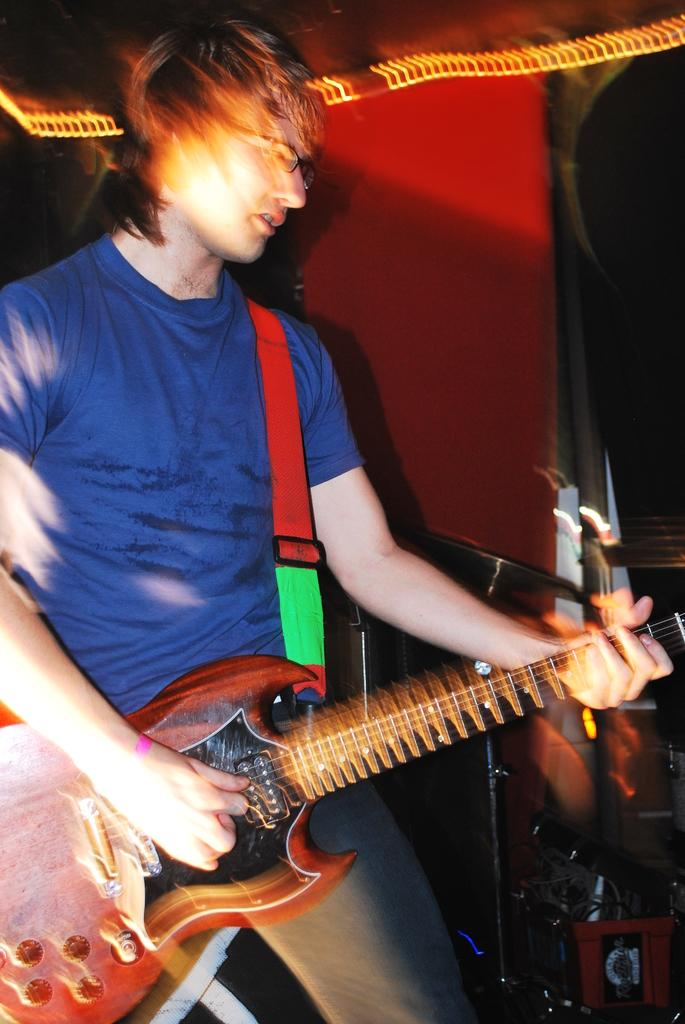What is the person in the image doing? The person is standing in the image and holding a guitar. What other musical instrument can be seen in the image? There is a drum plate in the image. How does the person's wealth affect the sea in the image? There is no sea present in the image, and the person's wealth is not mentioned or depicted. 